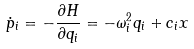<formula> <loc_0><loc_0><loc_500><loc_500>\dot { p } _ { i } = - \frac { \partial H } { \partial q _ { i } } = - \omega _ { i } ^ { 2 } q _ { i } + c _ { i } x</formula> 